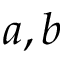<formula> <loc_0><loc_0><loc_500><loc_500>a , b</formula> 